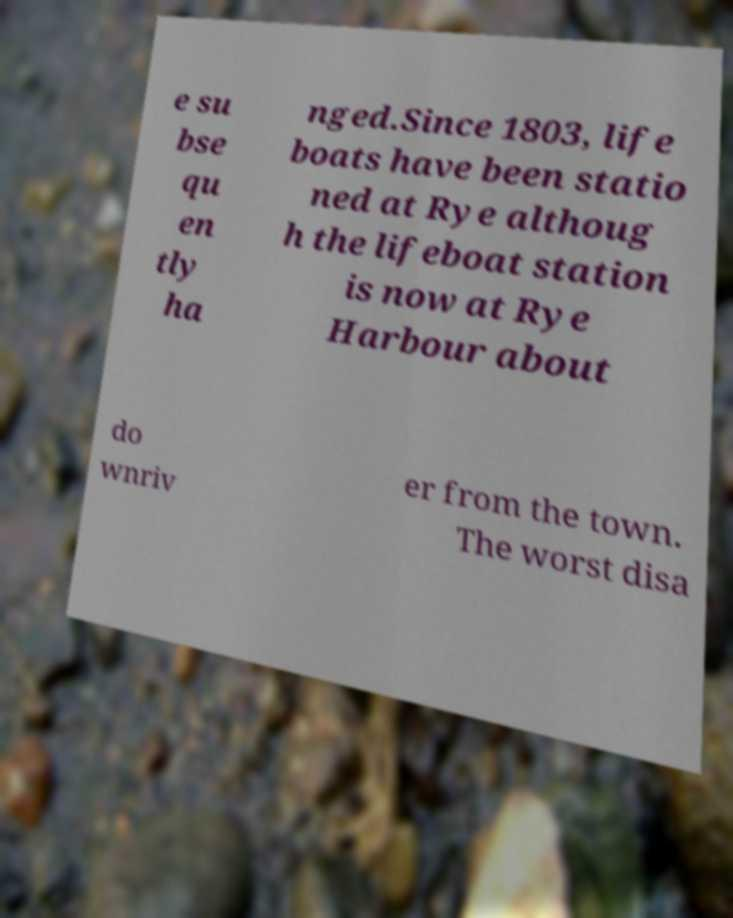Could you extract and type out the text from this image? e su bse qu en tly ha nged.Since 1803, life boats have been statio ned at Rye althoug h the lifeboat station is now at Rye Harbour about do wnriv er from the town. The worst disa 